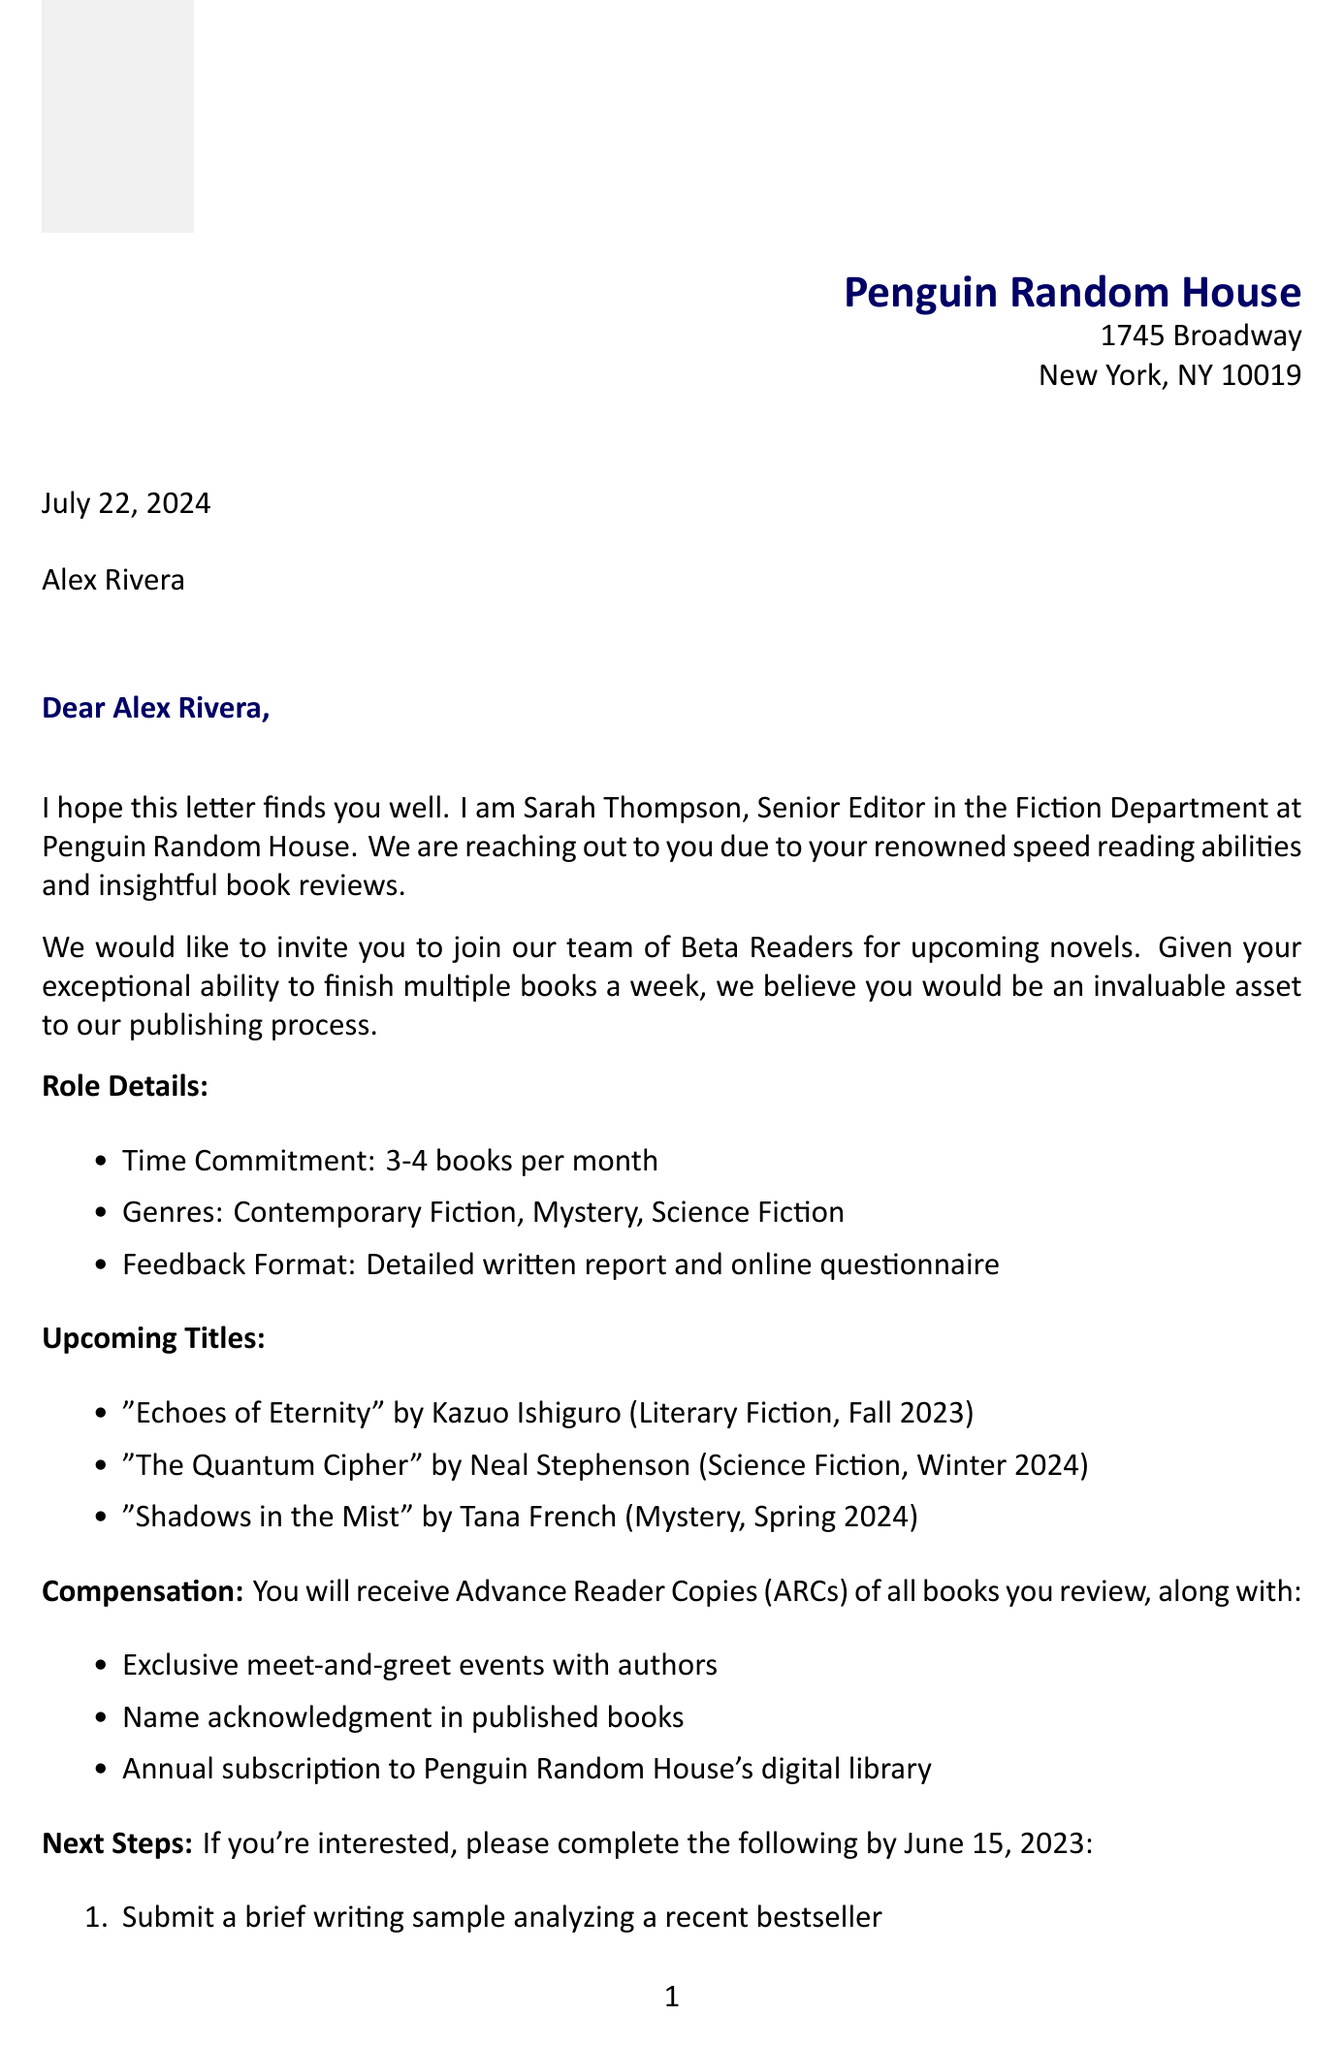What is the name of the publishing house? The publishing house mentioned in the document is called Penguin Random House.
Answer: Penguin Random House Who is the contact person for the invitation? The contact person for the invitation is Sarah Thompson, who is the Senior Editor in the Fiction Department.
Answer: Sarah Thompson What is the expected release date for "The Quantum Cipher"? The release date for "The Quantum Cipher" is stated as Winter 2024.
Answer: Winter 2024 How many books per month is the time commitment? The time commitment stated in the document is 3-4 books per month.
Answer: 3-4 books What type of compensation will the beta reader receive? The beta reader will receive Advance Reader Copies (ARCs) of all books reviewed.
Answer: Advance Reader Copies (ARCs) What is the deadline for responding to the invitation? The response is needed by June 15, 2023.
Answer: June 15, 2023 What is one of the key points for the confidentiality agreement? One key point is the non-disclosure of plot details.
Answer: Non-disclosure of plot details What is required to apply as a beta reader? Applicants are required to submit a brief writing sample analyzing a recent bestseller.
Answer: Submit a brief writing sample What is the genre of "Shadows in the Mist"? The genre of "Shadows in the Mist" is Mystery.
Answer: Mystery 